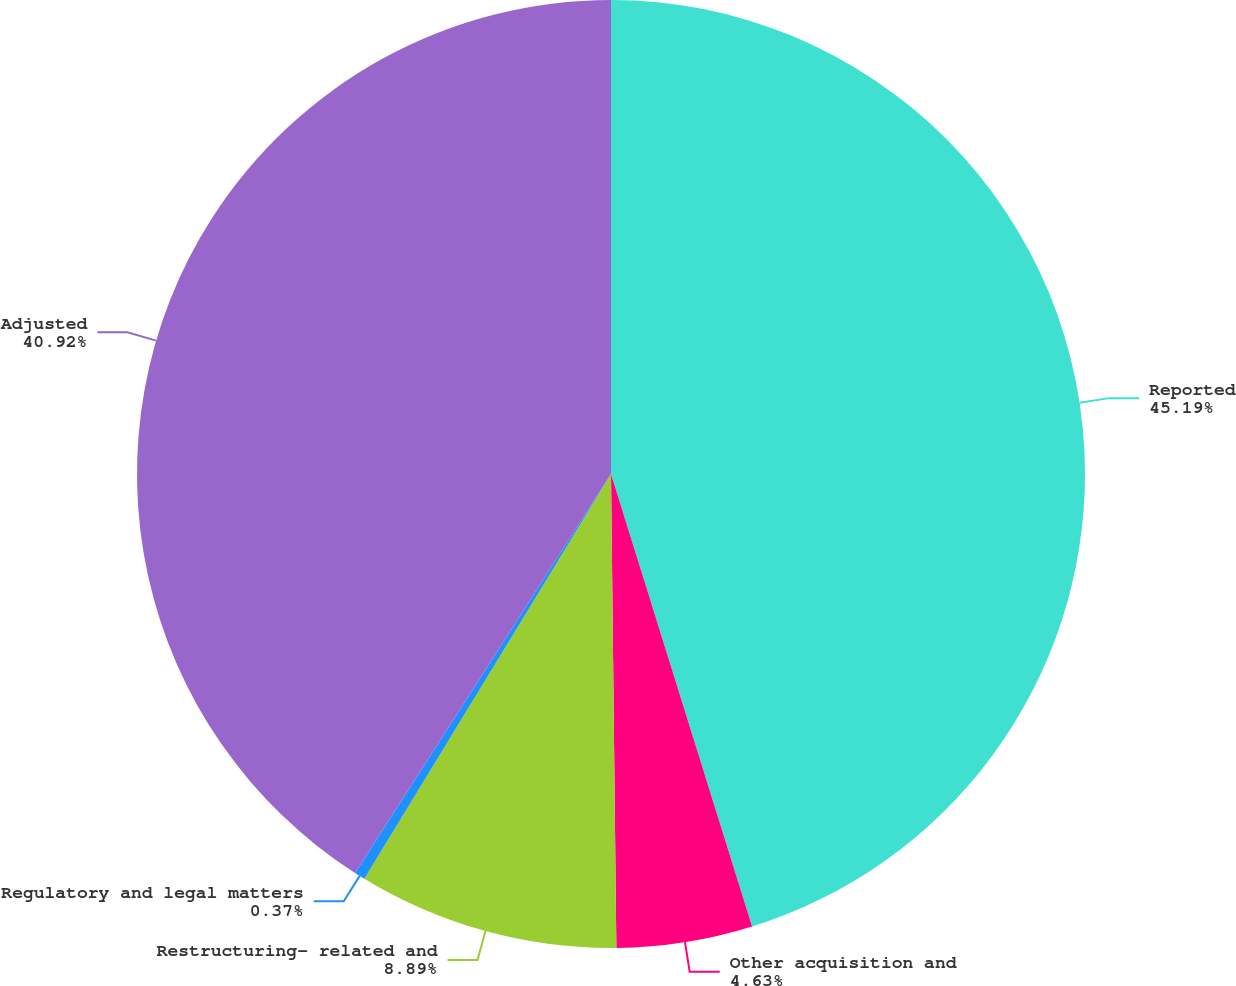Convert chart to OTSL. <chart><loc_0><loc_0><loc_500><loc_500><pie_chart><fcel>Reported<fcel>Other acquisition and<fcel>Restructuring- related and<fcel>Regulatory and legal matters<fcel>Adjusted<nl><fcel>45.19%<fcel>4.63%<fcel>8.89%<fcel>0.37%<fcel>40.92%<nl></chart> 